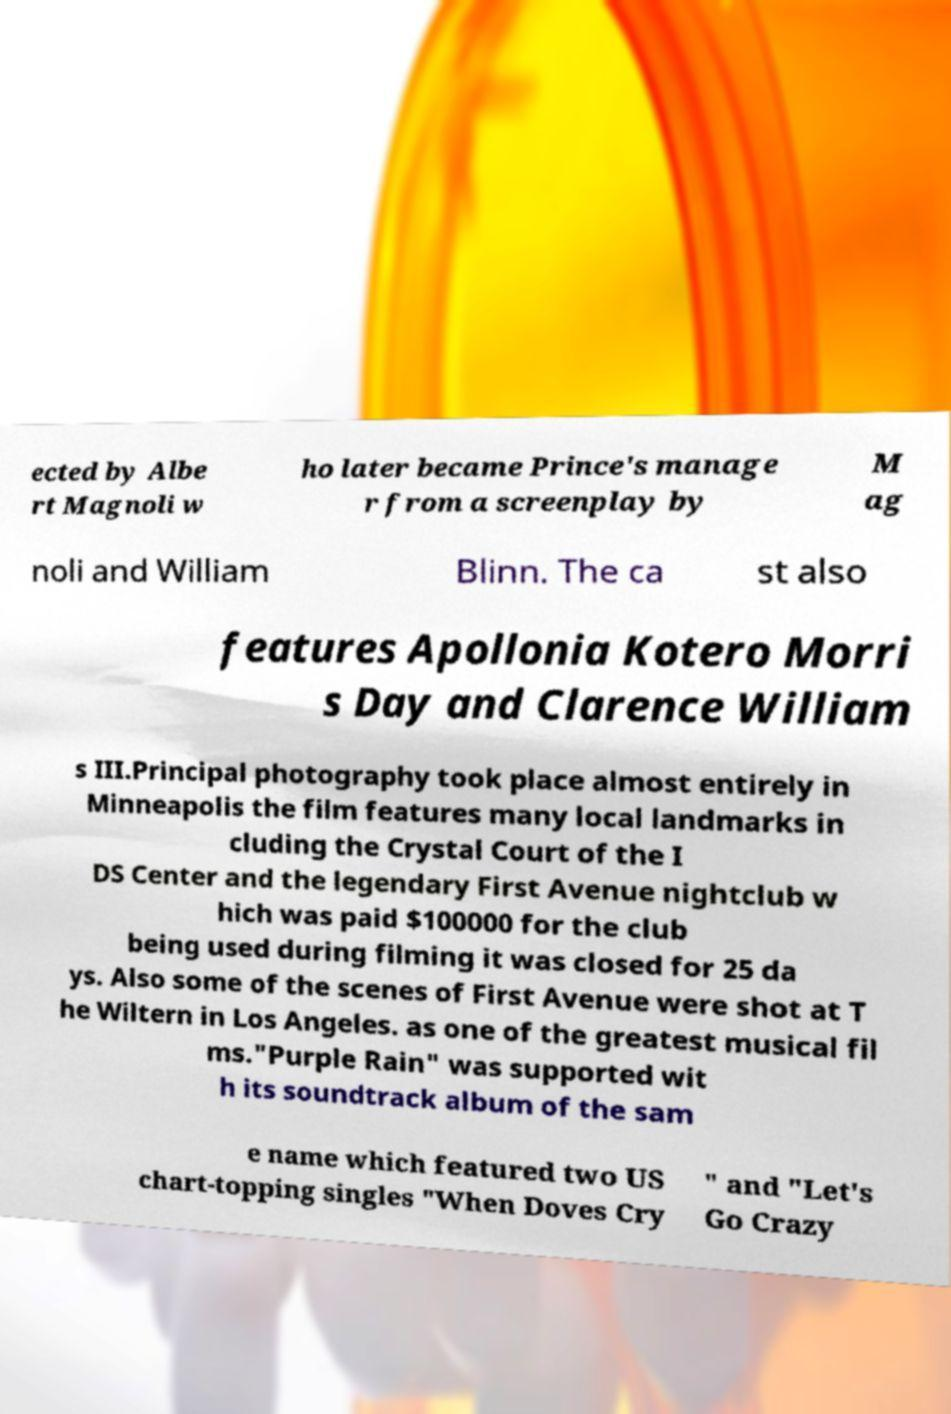Please read and relay the text visible in this image. What does it say? ected by Albe rt Magnoli w ho later became Prince's manage r from a screenplay by M ag noli and William Blinn. The ca st also features Apollonia Kotero Morri s Day and Clarence William s III.Principal photography took place almost entirely in Minneapolis the film features many local landmarks in cluding the Crystal Court of the I DS Center and the legendary First Avenue nightclub w hich was paid $100000 for the club being used during filming it was closed for 25 da ys. Also some of the scenes of First Avenue were shot at T he Wiltern in Los Angeles. as one of the greatest musical fil ms."Purple Rain" was supported wit h its soundtrack album of the sam e name which featured two US chart-topping singles "When Doves Cry " and "Let's Go Crazy 